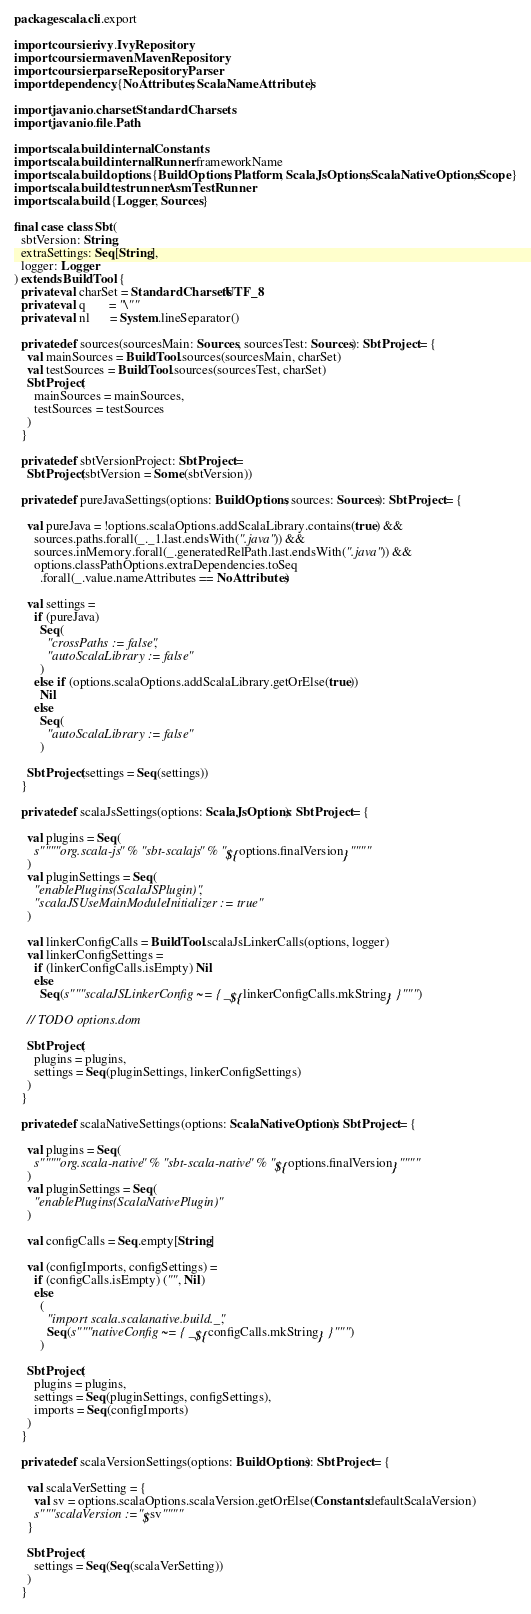Convert code to text. <code><loc_0><loc_0><loc_500><loc_500><_Scala_>package scala.cli.export

import coursier.ivy.IvyRepository
import coursier.maven.MavenRepository
import coursier.parse.RepositoryParser
import dependency.{NoAttributes, ScalaNameAttributes}

import java.nio.charset.StandardCharsets
import java.nio.file.Path

import scala.build.internal.Constants
import scala.build.internal.Runner.frameworkName
import scala.build.options.{BuildOptions, Platform, ScalaJsOptions, ScalaNativeOptions, Scope}
import scala.build.testrunner.AsmTestRunner
import scala.build.{Logger, Sources}

final case class Sbt(
  sbtVersion: String,
  extraSettings: Seq[String],
  logger: Logger
) extends BuildTool {
  private val charSet = StandardCharsets.UTF_8
  private val q       = "\""
  private val nl      = System.lineSeparator()

  private def sources(sourcesMain: Sources, sourcesTest: Sources): SbtProject = {
    val mainSources = BuildTool.sources(sourcesMain, charSet)
    val testSources = BuildTool.sources(sourcesTest, charSet)
    SbtProject(
      mainSources = mainSources,
      testSources = testSources
    )
  }

  private def sbtVersionProject: SbtProject =
    SbtProject(sbtVersion = Some(sbtVersion))

  private def pureJavaSettings(options: BuildOptions, sources: Sources): SbtProject = {

    val pureJava = !options.scalaOptions.addScalaLibrary.contains(true) &&
      sources.paths.forall(_._1.last.endsWith(".java")) &&
      sources.inMemory.forall(_.generatedRelPath.last.endsWith(".java")) &&
      options.classPathOptions.extraDependencies.toSeq
        .forall(_.value.nameAttributes == NoAttributes)

    val settings =
      if (pureJava)
        Seq(
          "crossPaths := false",
          "autoScalaLibrary := false"
        )
      else if (options.scalaOptions.addScalaLibrary.getOrElse(true))
        Nil
      else
        Seq(
          "autoScalaLibrary := false"
        )

    SbtProject(settings = Seq(settings))
  }

  private def scalaJsSettings(options: ScalaJsOptions): SbtProject = {

    val plugins = Seq(
      s""""org.scala-js" % "sbt-scalajs" % "${options.finalVersion}""""
    )
    val pluginSettings = Seq(
      "enablePlugins(ScalaJSPlugin)",
      "scalaJSUseMainModuleInitializer := true"
    )

    val linkerConfigCalls = BuildTool.scalaJsLinkerCalls(options, logger)
    val linkerConfigSettings =
      if (linkerConfigCalls.isEmpty) Nil
      else
        Seq(s"""scalaJSLinkerConfig ~= { _${linkerConfigCalls.mkString} }""")

    // TODO options.dom

    SbtProject(
      plugins = plugins,
      settings = Seq(pluginSettings, linkerConfigSettings)
    )
  }

  private def scalaNativeSettings(options: ScalaNativeOptions): SbtProject = {

    val plugins = Seq(
      s""""org.scala-native" % "sbt-scala-native" % "${options.finalVersion}""""
    )
    val pluginSettings = Seq(
      "enablePlugins(ScalaNativePlugin)"
    )

    val configCalls = Seq.empty[String]

    val (configImports, configSettings) =
      if (configCalls.isEmpty) ("", Nil)
      else
        (
          "import scala.scalanative.build._",
          Seq(s"""nativeConfig ~= { _${configCalls.mkString} }""")
        )

    SbtProject(
      plugins = plugins,
      settings = Seq(pluginSettings, configSettings),
      imports = Seq(configImports)
    )
  }

  private def scalaVersionSettings(options: BuildOptions): SbtProject = {

    val scalaVerSetting = {
      val sv = options.scalaOptions.scalaVersion.getOrElse(Constants.defaultScalaVersion)
      s"""scalaVersion := "$sv""""
    }

    SbtProject(
      settings = Seq(Seq(scalaVerSetting))
    )
  }
</code> 